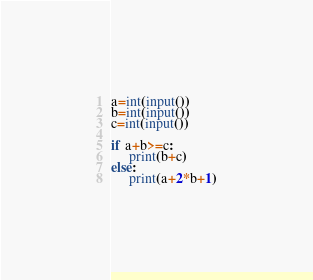Convert code to text. <code><loc_0><loc_0><loc_500><loc_500><_Python_>a=int(input())
b=int(input())
c=int(input())

if a+b>=c:
     print(b+c)
else:
     print(a+2*b+1)</code> 